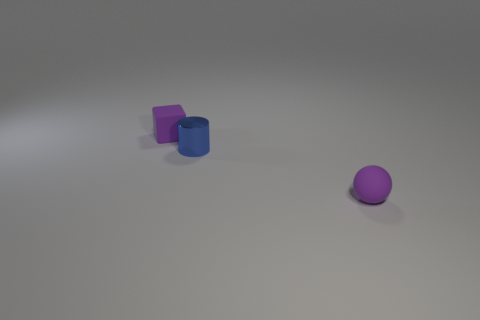Add 1 yellow cubes. How many objects exist? 4 Subtract all cubes. How many objects are left? 2 Add 3 small purple blocks. How many small purple blocks are left? 4 Add 1 tiny objects. How many tiny objects exist? 4 Subtract 0 gray cubes. How many objects are left? 3 Subtract all purple shiny cubes. Subtract all small spheres. How many objects are left? 2 